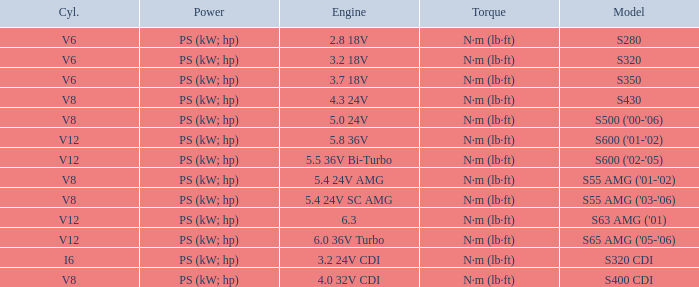Which Engine has a Model of s430? 4.3 24V. 